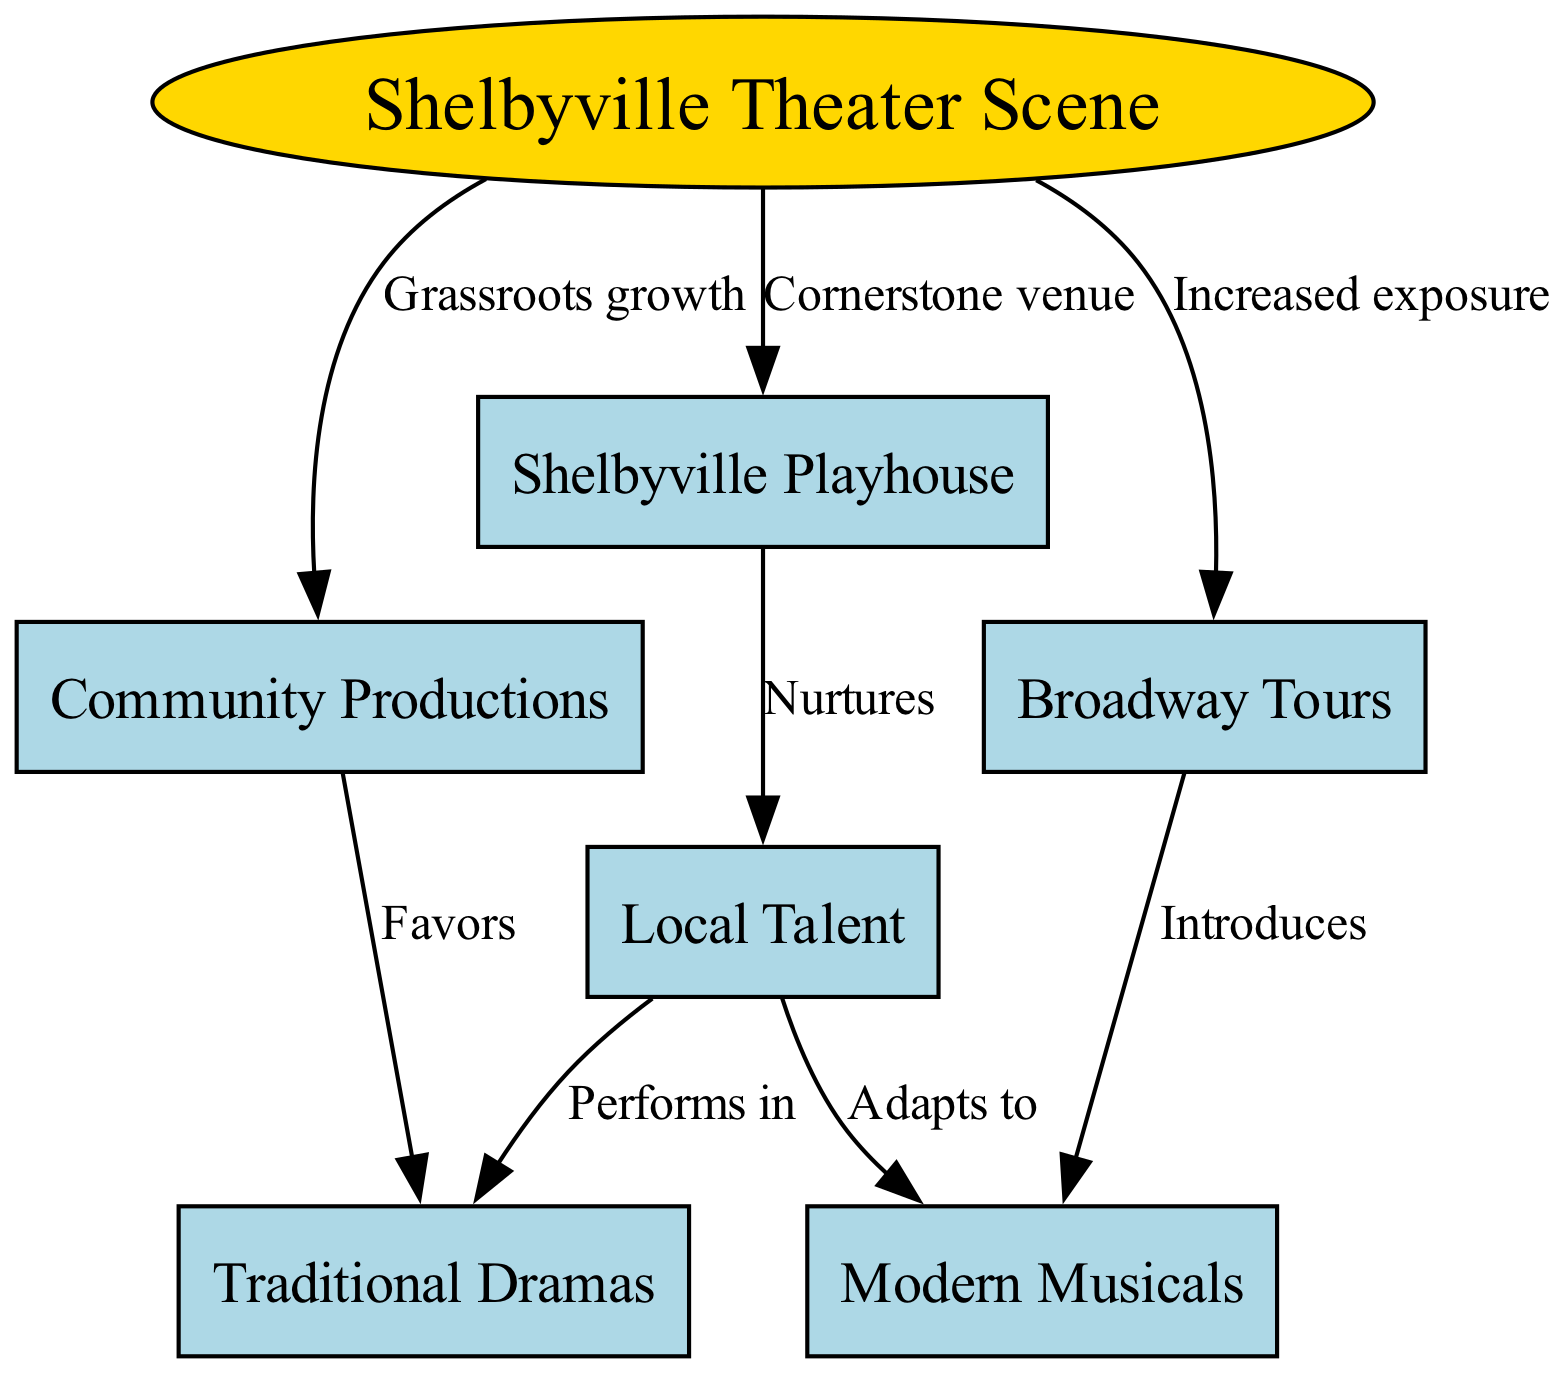What is the cornerstone venue of the Shelbyville theater scene? The diagram indicates that the Shelbyville Playhouse is labeled as the "Cornerstone venue" in relation to the Shelbyville Theater Scene. This direct connection shows the importance of this venue in the overall structure of the theater scene.
Answer: Shelbyville Playhouse How many nodes are represented in the diagram? By counting the nodes listed in the diagram, we can see that there are a total of 7 nodes presented. This includes all the main elements of the theater scene and its associated components.
Answer: 7 What type of productions does the Shelbyville Playhouse nurture? The diagram specifies that the Shelbyville Playhouse "Nurtures" local talent. This depicts the role the Playhouse plays in supporting and developing artists and performers within the community.
Answer: Local Talent Which aspect of community productions does the diagram favor? According to the diagram, community productions "Favors" traditional dramas, indicating a strong preference for this genre within community initiatives. This suggests that such productions often focus on these classical narratives.
Answer: Traditional Dramas What does the diagram say about Broadway tours? The diagram shows that Broadway tours "Introduces" modern musicals, indicating their role in bringing contemporary musical theater to the local audience. This reflects how external productions can influence and diversify the local theater landscape.
Answer: Modern Musicals How do local talents adapt their performances according to the diagram? The diagram shows a relationship where local talent "Adapts to" modern musicals. This demonstrates how local performers are evolving and changing their skill set to align with current trends in theatrical productions.
Answer: Modern Musicals What relationship does community productions have with traditional dramas? The diagram indicates that community productions "Favors" traditional dramas, showing a direct connection where local community efforts prioritize these types of productions over others.
Answer: Favors 